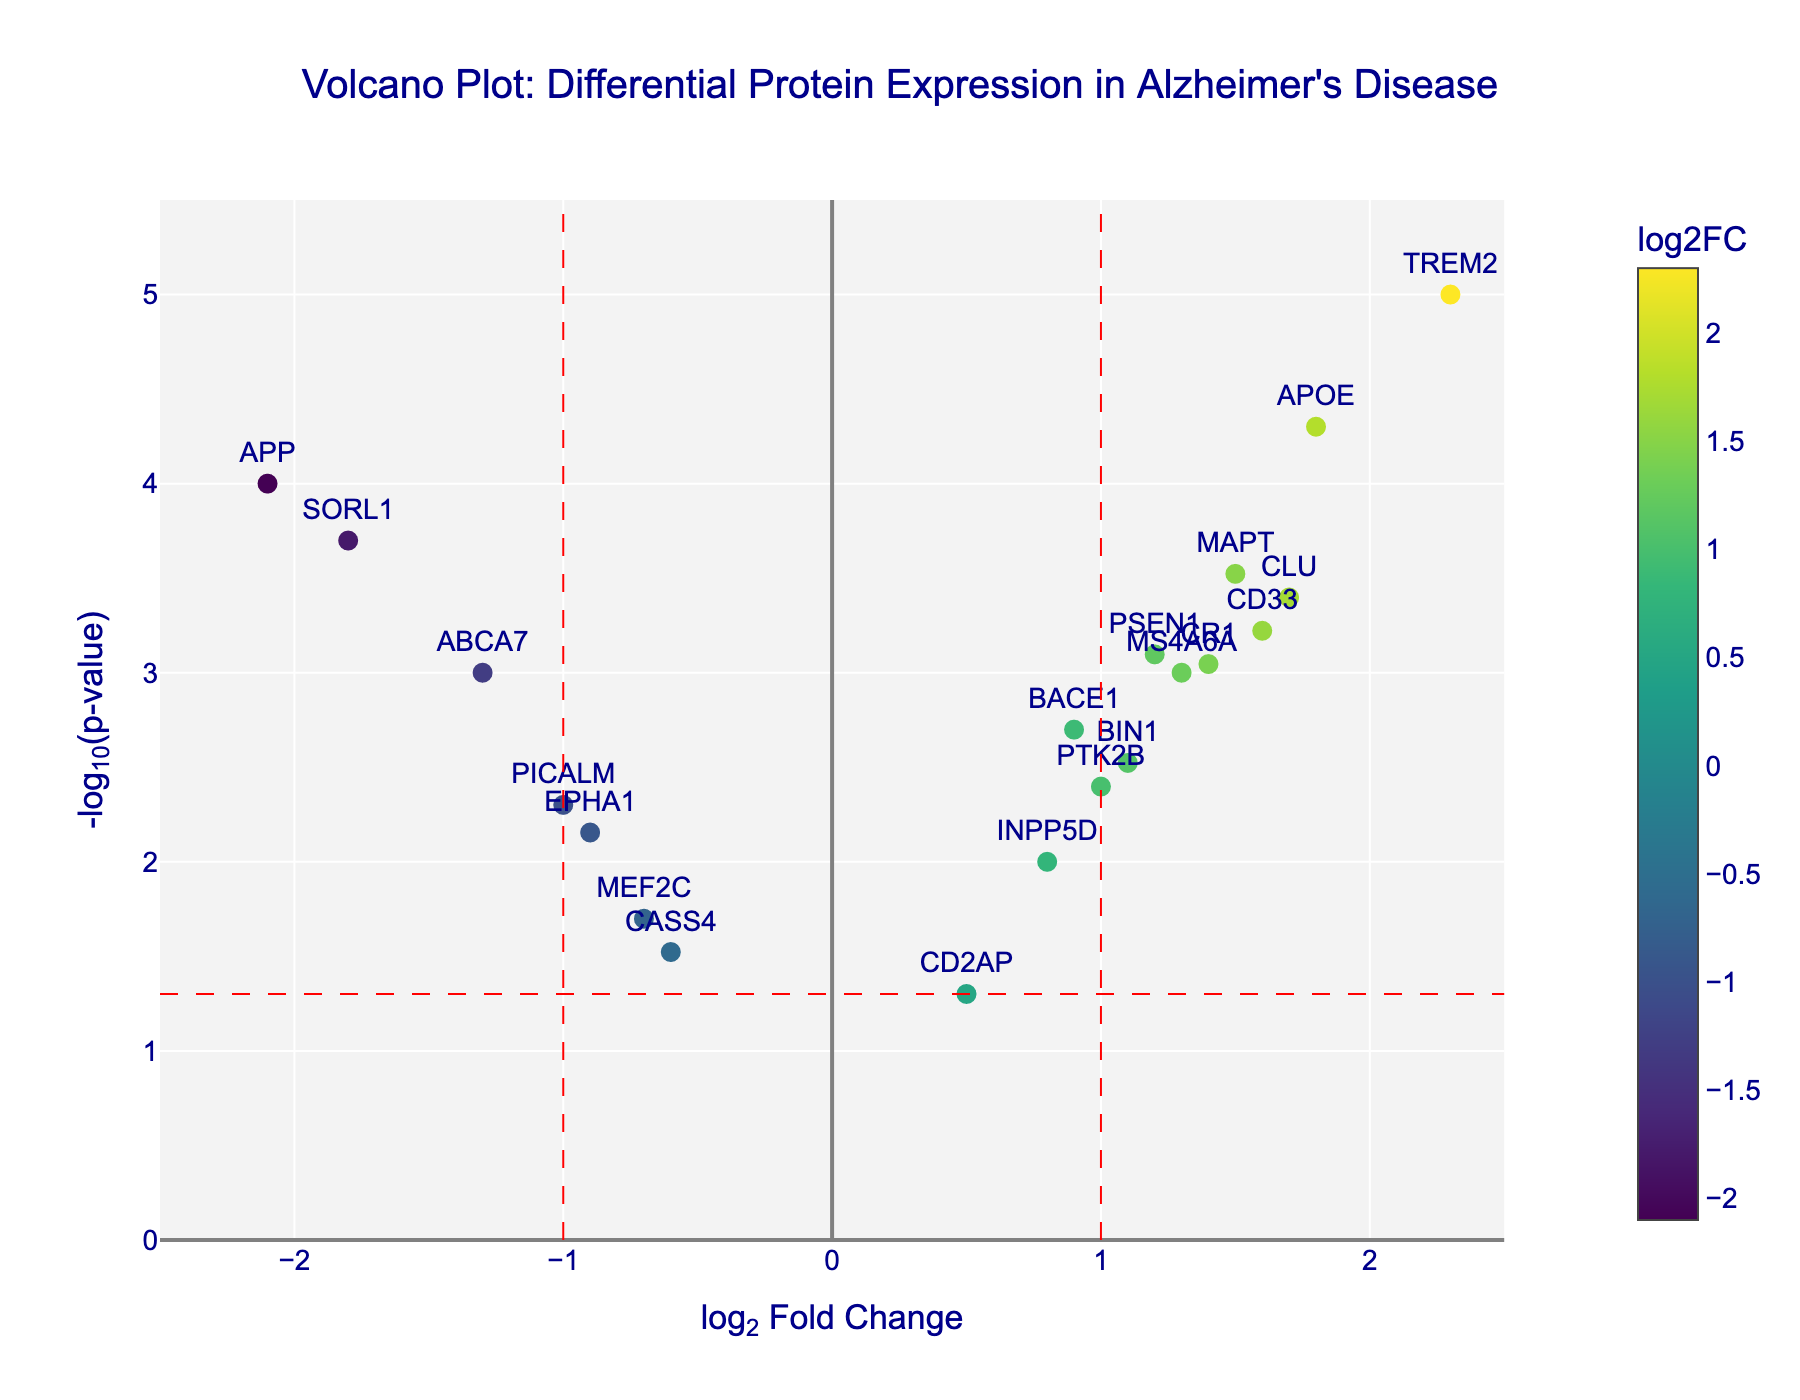What is the title of the figure? The title of the figure is located at the top and indicates the purpose of the visualized data. The title reads, "Volcano Plot: Differential Protein Expression in Alzheimer's Disease," summarizing the content.
Answer: Volcano Plot: Differential Protein Expression in Alzheimer's Disease What do the x-axis and y-axis represent in this plot? The x-axis represents the log2 Fold Change (log2FC), which shows the fold change of protein expression between Alzheimer's disease patients and healthy controls. The y-axis represents -log10(p-value), indicating the significance of the differential expression.
Answer: x-axis: log2 Fold Change, y-axis: -log10(p-value) Which protein shows the highest level of statistical significance in the plot? By looking at the highest -log10(p-value) on the y-axis, we can find that TREM2 has the highest statistical significance. It is visually the highest point in the plot.
Answer: TREM2 Are there any proteins with log2 Fold Change values between -1.0 and 1.0 and what are they? Points within this range on the x-axis include BACE1, BIN1, PTK2B, INPP5D, PICALM, CASS4, and EPHA1. Checking the labels within the range confirms these proteins.
Answer: BACE1, BIN1, PTK2B, INPP5D, PICALM, CASS4, EPHA1 Which proteins have a negative log2 Fold Change and are significantly different (below the red horizontal line) with p-values less than 0.05? To find this, identify the points on the left side of the y-axis (negative log2FC) and below the dashed horizontal line, corresponding to p-values less than 0.05. These proteins are APP, ABCA7, and SORL1.
Answer: APP, ABCA7, SORL1 What is the log2 Fold Change for APOE, and how statistically significant is it? Refer to the specific point for APOE on the plot to obtain its log2FC and -log10(p-value). The hover text confirms APOE's log2FC is 1.8 and the p-value is 0.00005.
Answer: log2FC: 1.8, p-value: 0.00005 Which proteins have a higher log2 Fold Change than PSEN1, and what are their p-values? Compare PSEN1’s log2FC (1.2) with other proteins'. The proteins with higher log2FC are APOE (1.8, p=0.00005), TREM2 (2.3, p=0.00001), CLU (1.7, p=0.0004), and CD33 (1.6, p=0.0006).
Answer: APOE (p=0.00005), TREM2 (p=0.00001), CLU (p=0.0004), CD33 (p=0.0006) How many proteins show significant upregulation (log2 Fold Change > 1 and p-value < 0.05)? Count the points with log2FC > 1 situated above the red horizontal line, confirming the p-value < 0.05. These are APOE, PSEN1, TREM2, CLU, CD33, and CR1.
Answer: 6 Which proteins show a log2 Fold Change of less than -1 and a p-value of less than 0.005? Points to the left of -1 on the x-axis and above the corresponding point for -log10(0.005) on the y-axis represent these proteins. They are APP and SORL1.
Answer: APP, SORL1 